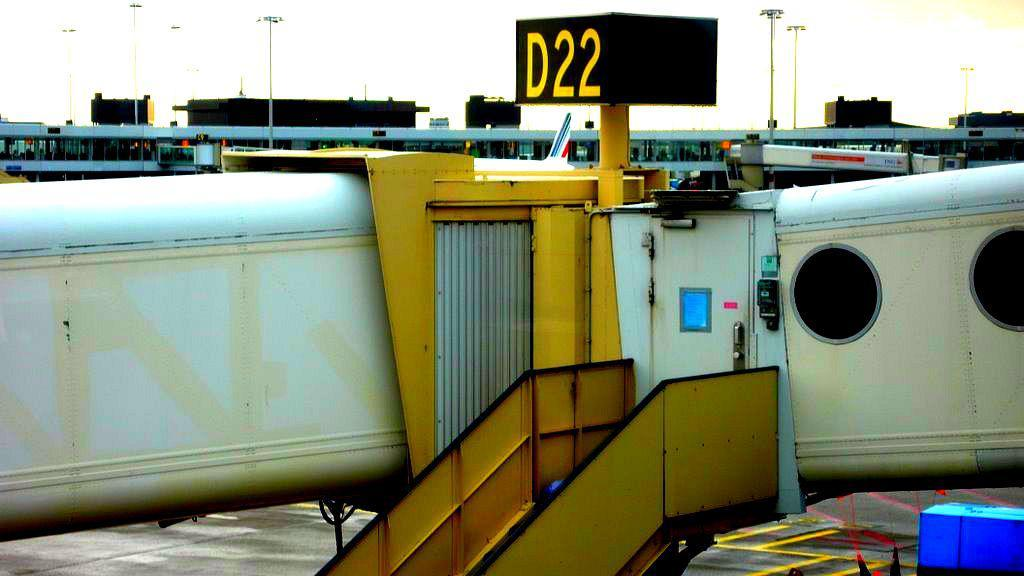<image>
Summarize the visual content of the image. Airplane parked in an area with a sign which says D22. 